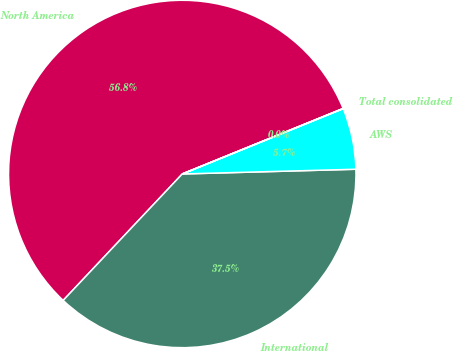<chart> <loc_0><loc_0><loc_500><loc_500><pie_chart><fcel>North America<fcel>International<fcel>AWS<fcel>Total consolidated<nl><fcel>56.82%<fcel>37.46%<fcel>5.7%<fcel>0.02%<nl></chart> 